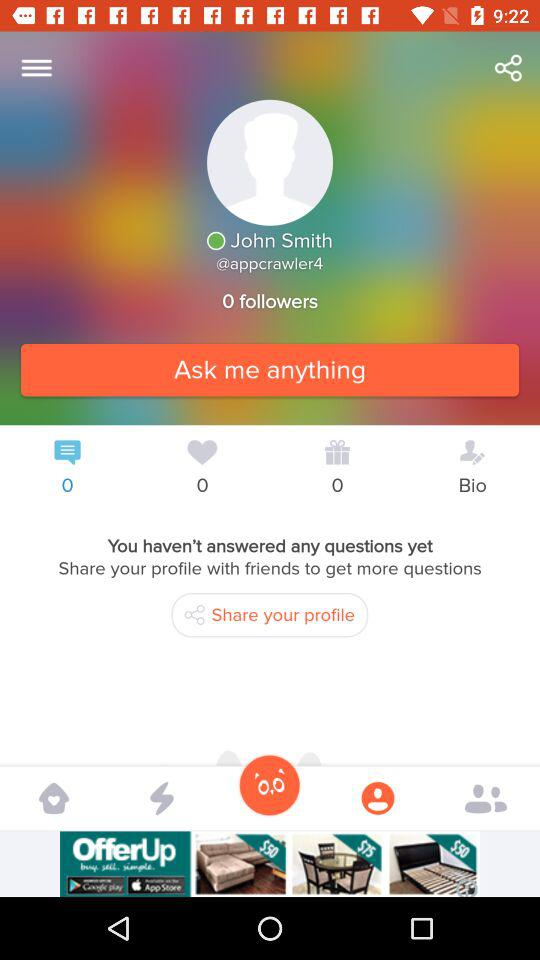How many followers does John Smith have?
Answer the question using a single word or phrase. 0 